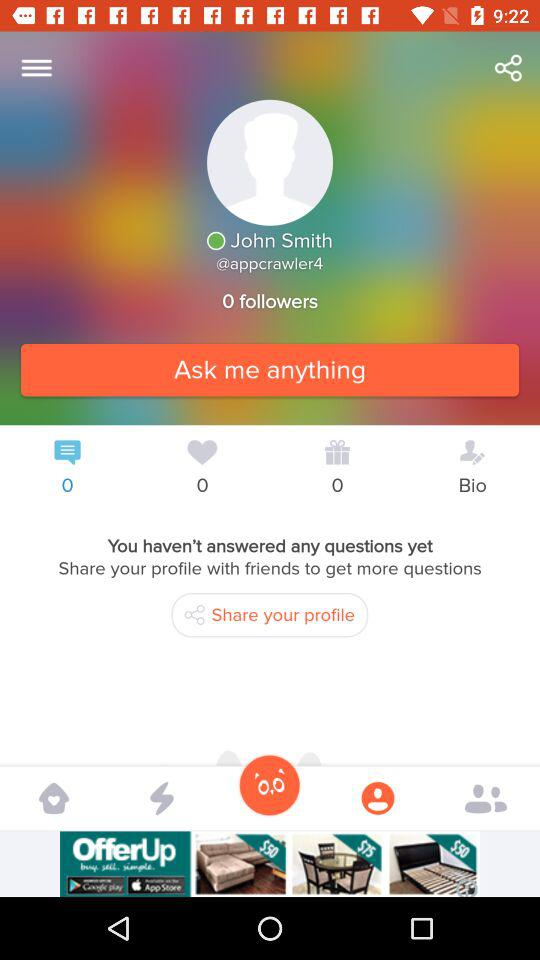How many followers does John Smith have?
Answer the question using a single word or phrase. 0 